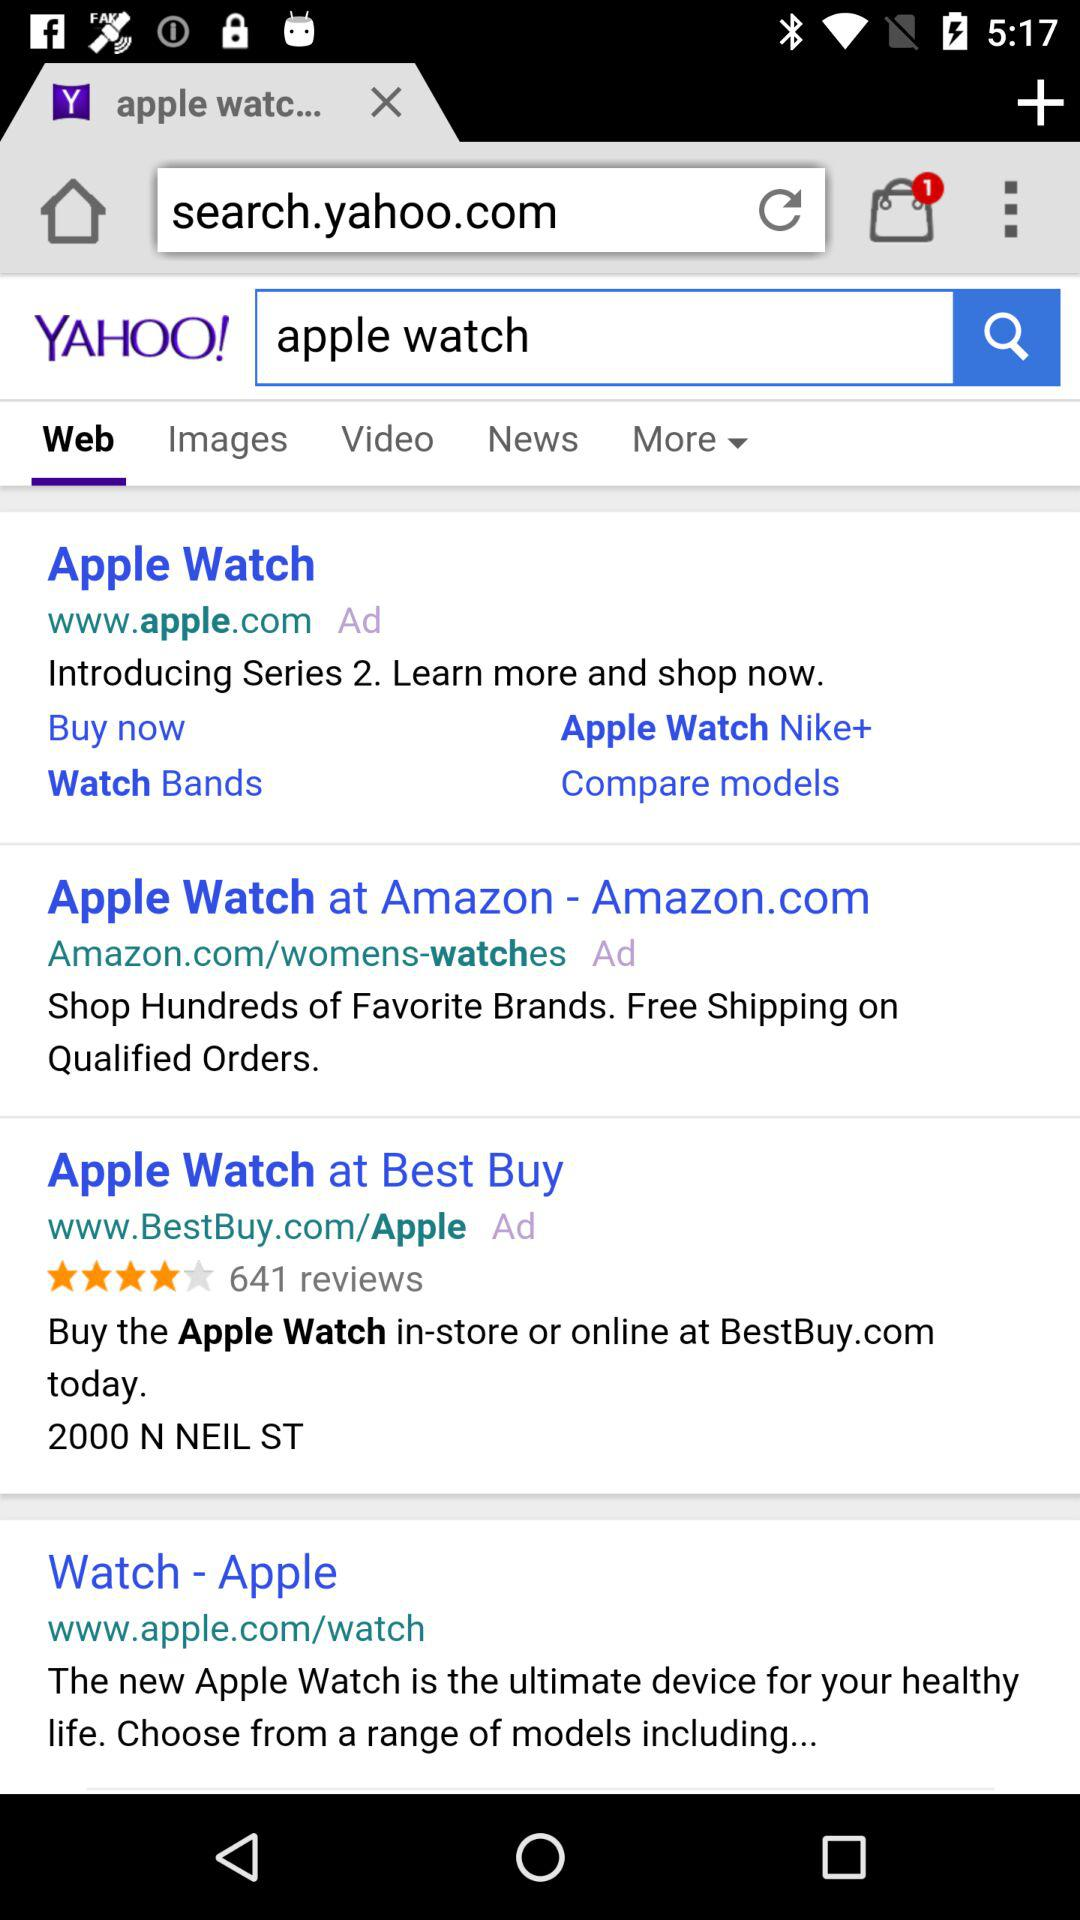Which option is selected in the YAHOO? The selected option is "Web". 